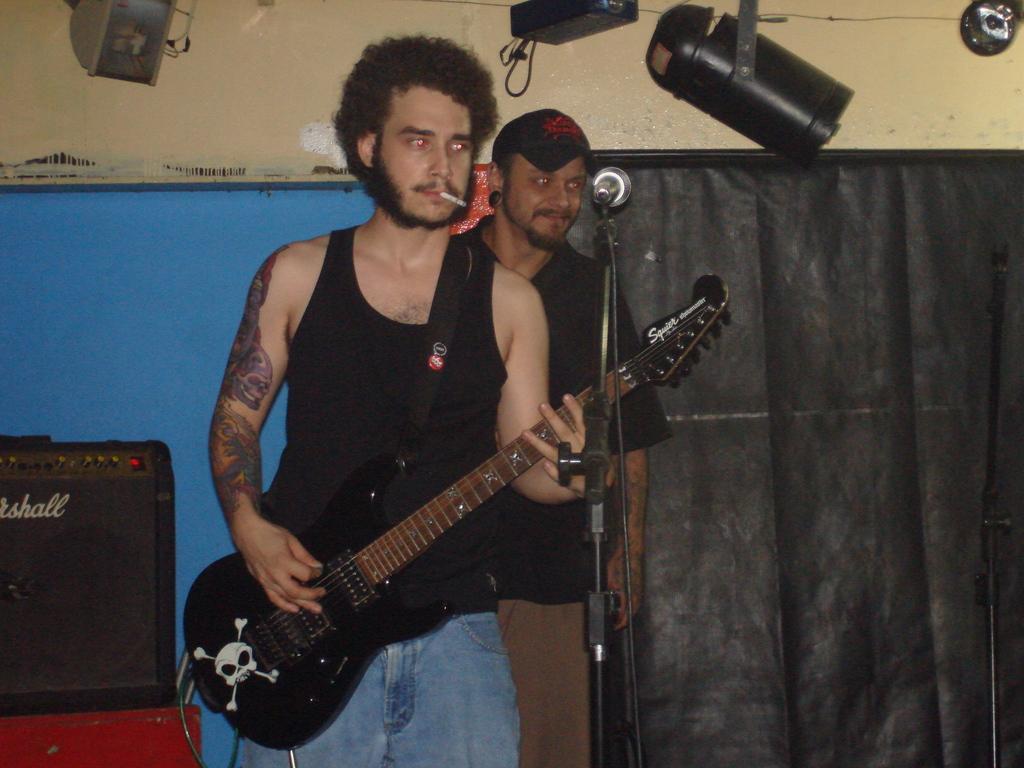Can you describe this image briefly? there is a man holding a guitar is smoking and the other man at his back is smiling. 